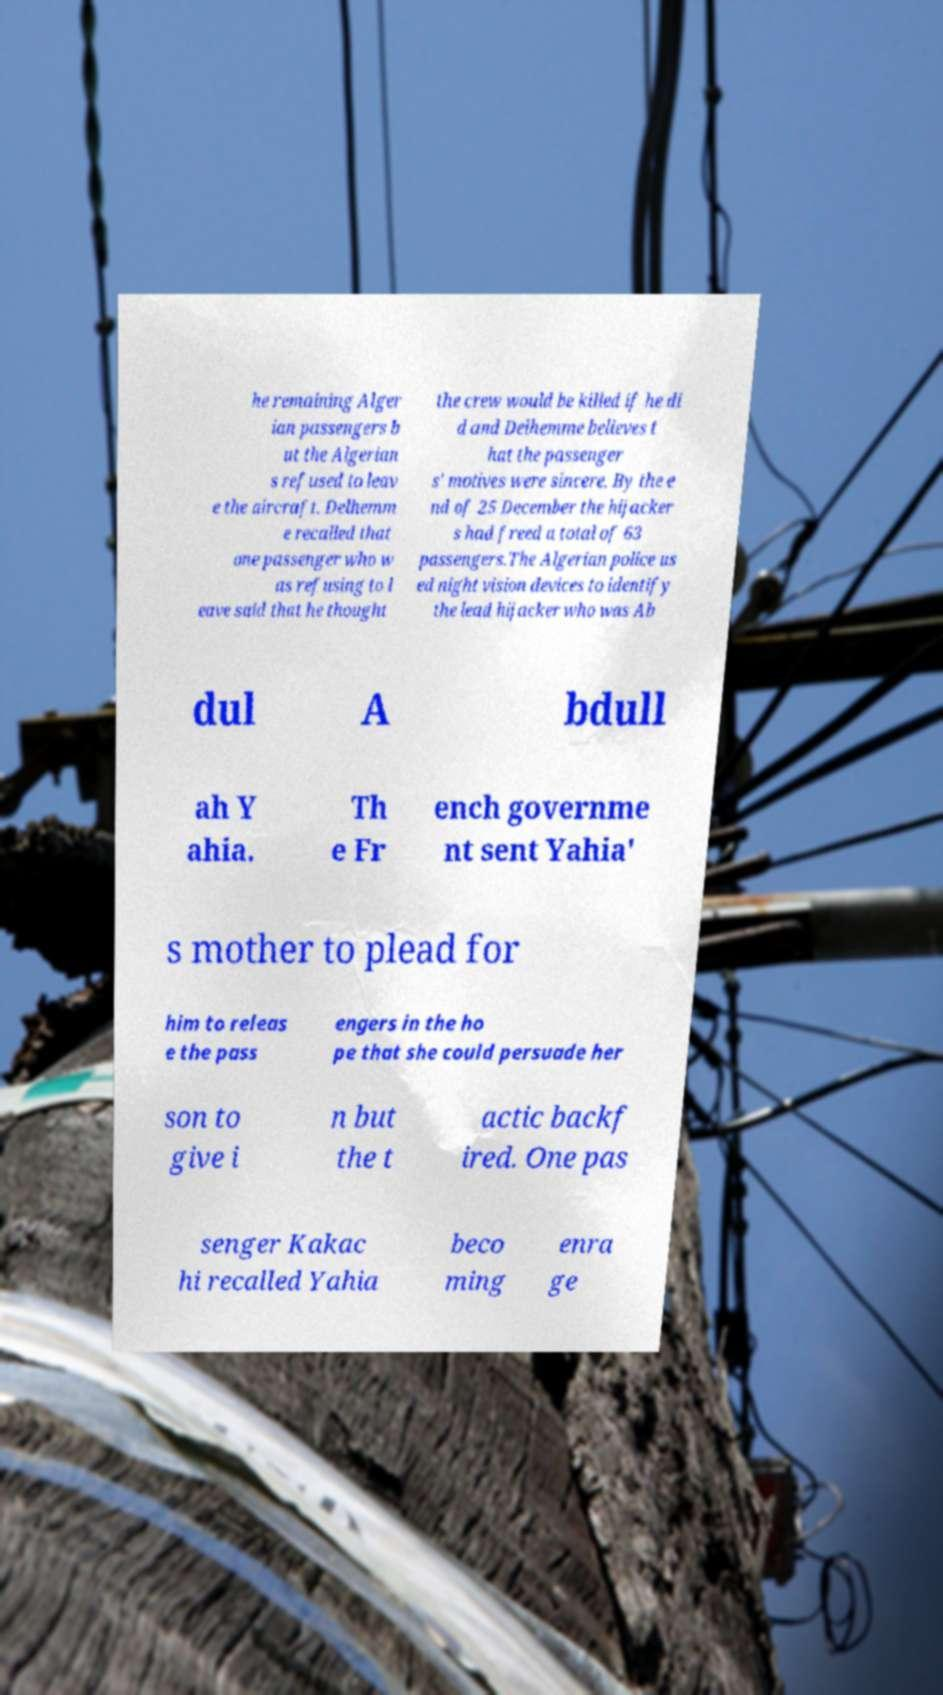Can you read and provide the text displayed in the image?This photo seems to have some interesting text. Can you extract and type it out for me? he remaining Alger ian passengers b ut the Algerian s refused to leav e the aircraft. Delhemm e recalled that one passenger who w as refusing to l eave said that he thought the crew would be killed if he di d and Delhemme believes t hat the passenger s' motives were sincere. By the e nd of 25 December the hijacker s had freed a total of 63 passengers.The Algerian police us ed night vision devices to identify the lead hijacker who was Ab dul A bdull ah Y ahia. Th e Fr ench governme nt sent Yahia' s mother to plead for him to releas e the pass engers in the ho pe that she could persuade her son to give i n but the t actic backf ired. One pas senger Kakac hi recalled Yahia beco ming enra ge 